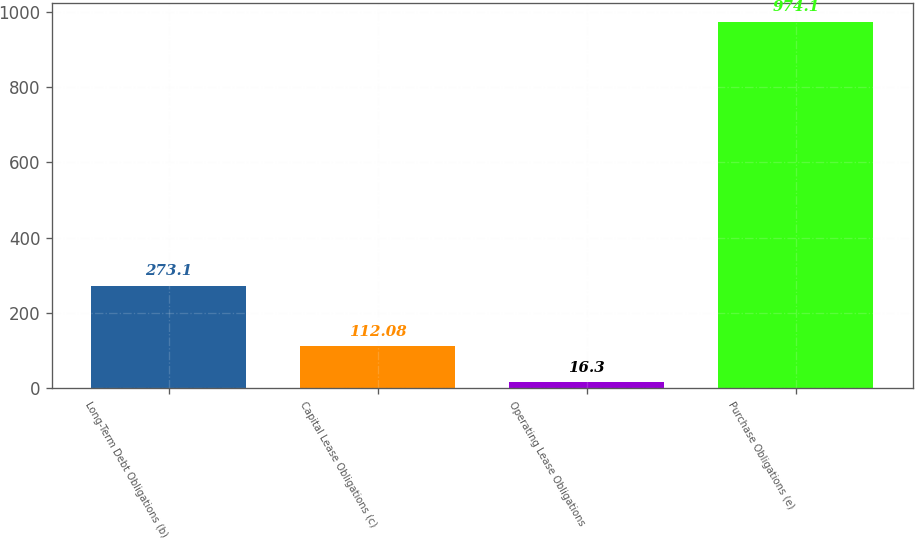Convert chart to OTSL. <chart><loc_0><loc_0><loc_500><loc_500><bar_chart><fcel>Long-Term Debt Obligations (b)<fcel>Capital Lease Obligations (c)<fcel>Operating Lease Obligations<fcel>Purchase Obligations (e)<nl><fcel>273.1<fcel>112.08<fcel>16.3<fcel>974.1<nl></chart> 